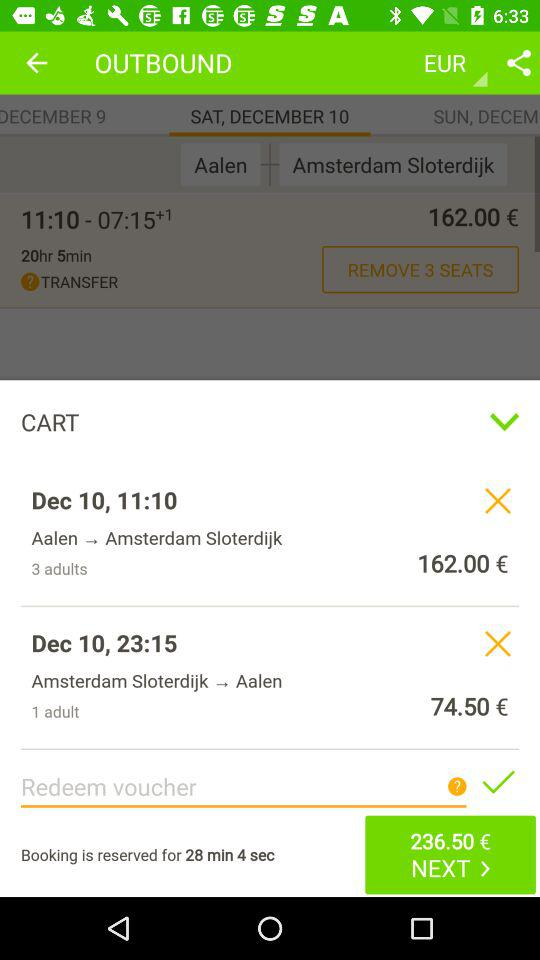What is the price of "Amsterdam Sloterdijk to Aalen"? The price is 74.50 €. 